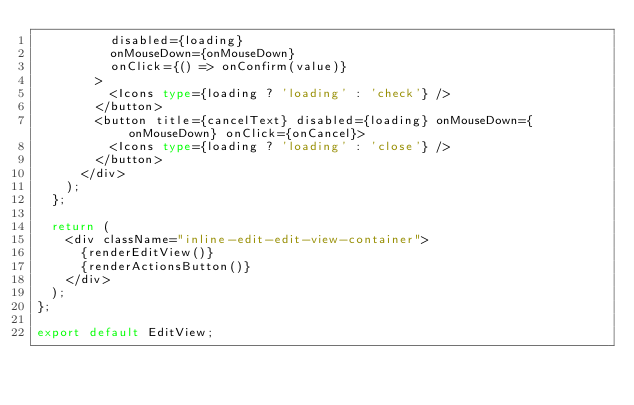Convert code to text. <code><loc_0><loc_0><loc_500><loc_500><_TypeScript_>          disabled={loading}
          onMouseDown={onMouseDown}
          onClick={() => onConfirm(value)}
        >
          <Icons type={loading ? 'loading' : 'check'} />
        </button>
        <button title={cancelText} disabled={loading} onMouseDown={onMouseDown} onClick={onCancel}>
          <Icons type={loading ? 'loading' : 'close'} />
        </button>
      </div>
    );
  };

  return (
    <div className="inline-edit-edit-view-container">
      {renderEditView()}
      {renderActionsButton()}
    </div>
  );
};

export default EditView;
</code> 